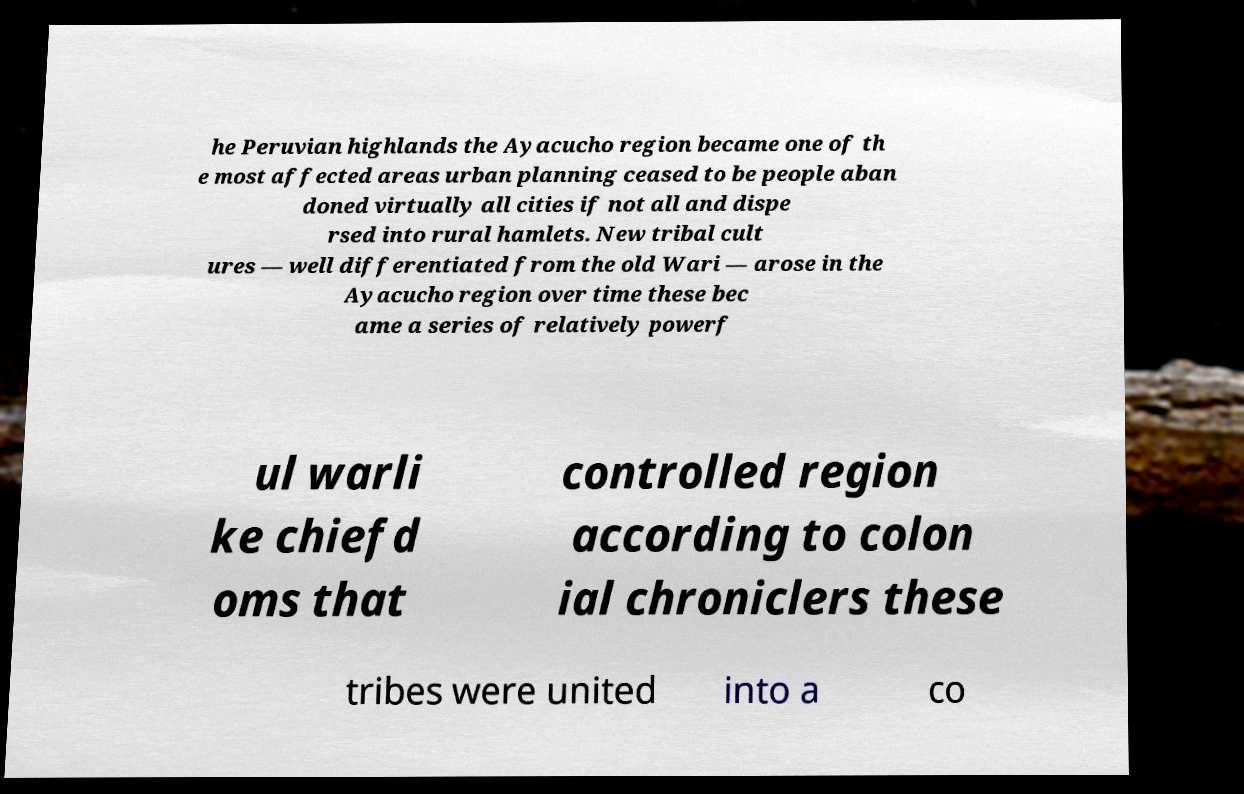Can you read and provide the text displayed in the image?This photo seems to have some interesting text. Can you extract and type it out for me? he Peruvian highlands the Ayacucho region became one of th e most affected areas urban planning ceased to be people aban doned virtually all cities if not all and dispe rsed into rural hamlets. New tribal cult ures — well differentiated from the old Wari — arose in the Ayacucho region over time these bec ame a series of relatively powerf ul warli ke chiefd oms that controlled region according to colon ial chroniclers these tribes were united into a co 